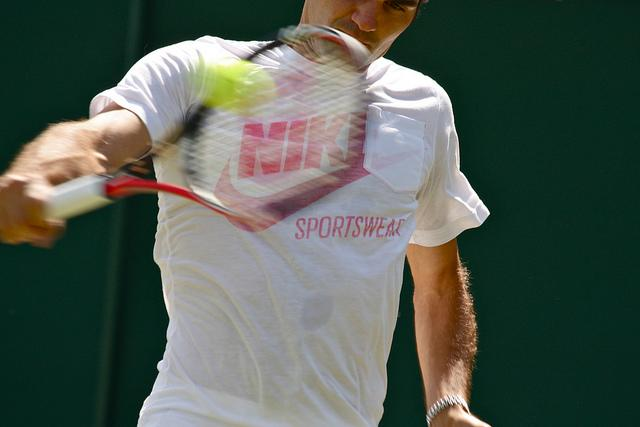Which country houses the headquarter of the brand company manufacturing the man's shirt? usa 